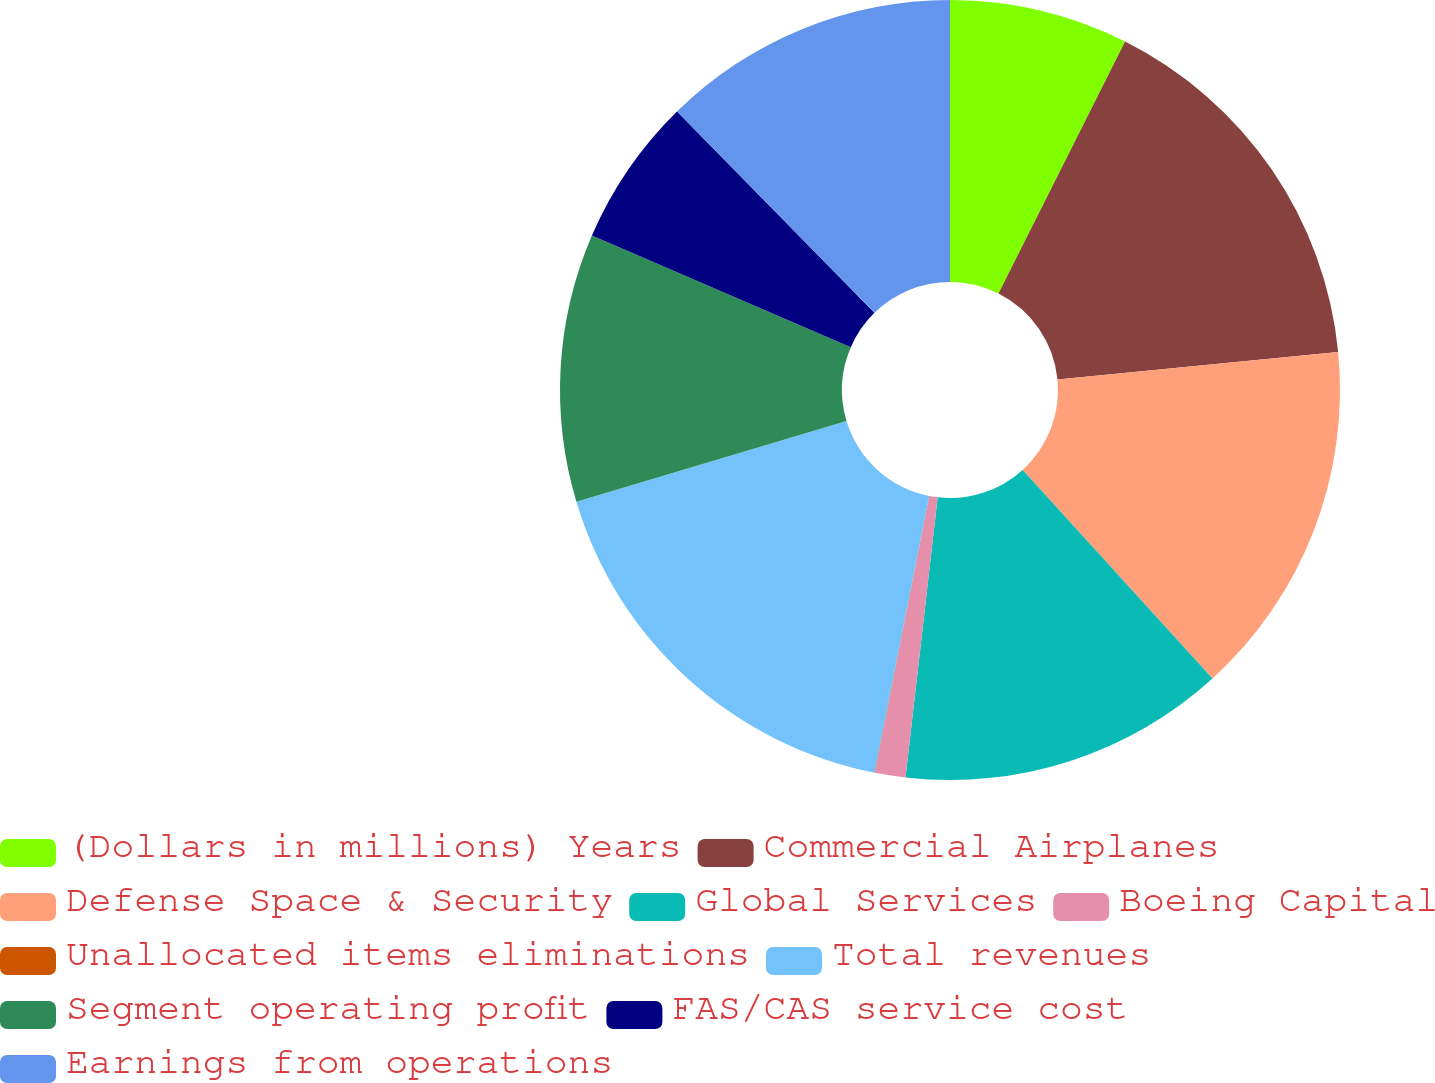Convert chart to OTSL. <chart><loc_0><loc_0><loc_500><loc_500><pie_chart><fcel>(Dollars in millions) Years<fcel>Commercial Airplanes<fcel>Defense Space & Security<fcel>Global Services<fcel>Boeing Capital<fcel>Unallocated items eliminations<fcel>Total revenues<fcel>Segment operating profit<fcel>FAS/CAS service cost<fcel>Earnings from operations<nl><fcel>7.41%<fcel>16.04%<fcel>14.8%<fcel>13.57%<fcel>1.26%<fcel>0.02%<fcel>17.27%<fcel>11.11%<fcel>6.18%<fcel>12.34%<nl></chart> 